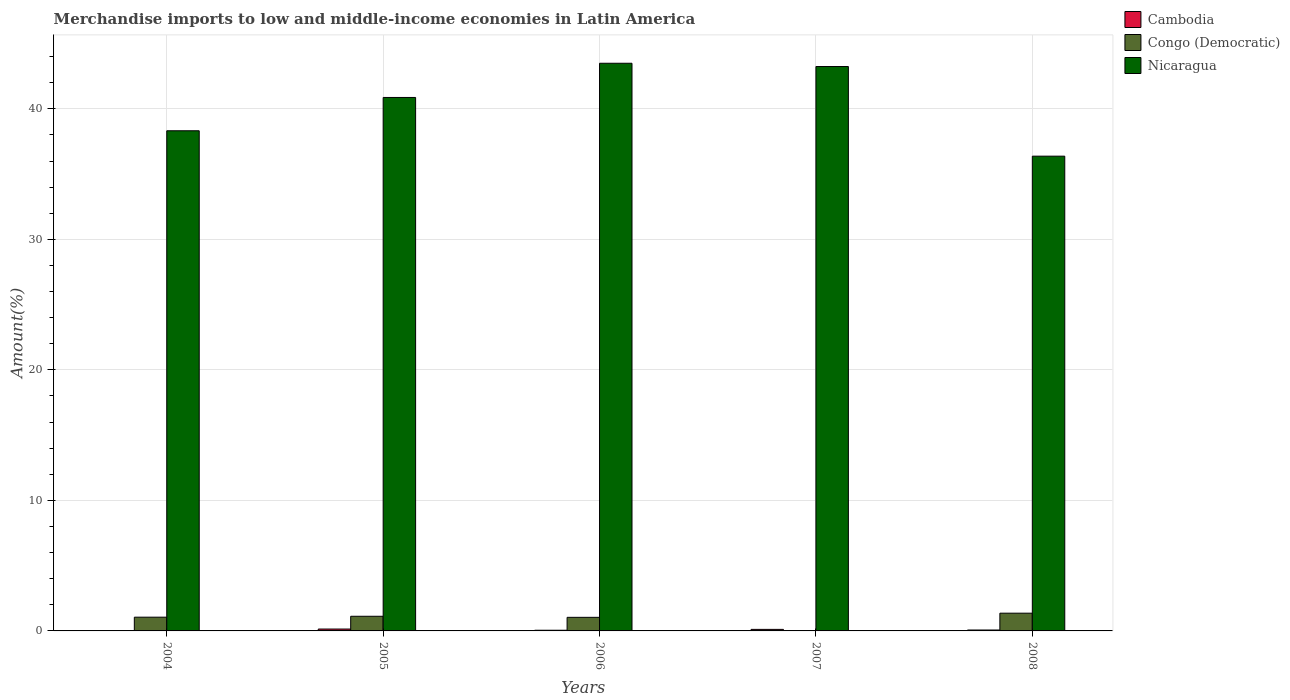Are the number of bars per tick equal to the number of legend labels?
Ensure brevity in your answer.  Yes. Are the number of bars on each tick of the X-axis equal?
Ensure brevity in your answer.  Yes. How many bars are there on the 5th tick from the left?
Make the answer very short. 3. How many bars are there on the 5th tick from the right?
Your answer should be compact. 3. In how many cases, is the number of bars for a given year not equal to the number of legend labels?
Provide a short and direct response. 0. What is the percentage of amount earned from merchandise imports in Cambodia in 2007?
Ensure brevity in your answer.  0.12. Across all years, what is the maximum percentage of amount earned from merchandise imports in Cambodia?
Give a very brief answer. 0.14. Across all years, what is the minimum percentage of amount earned from merchandise imports in Congo (Democratic)?
Offer a terse response. 0.03. In which year was the percentage of amount earned from merchandise imports in Cambodia minimum?
Give a very brief answer. 2004. What is the total percentage of amount earned from merchandise imports in Congo (Democratic) in the graph?
Provide a short and direct response. 4.6. What is the difference between the percentage of amount earned from merchandise imports in Congo (Democratic) in 2006 and that in 2008?
Provide a short and direct response. -0.32. What is the difference between the percentage of amount earned from merchandise imports in Nicaragua in 2008 and the percentage of amount earned from merchandise imports in Cambodia in 2006?
Ensure brevity in your answer.  36.32. What is the average percentage of amount earned from merchandise imports in Nicaragua per year?
Offer a terse response. 40.46. In the year 2005, what is the difference between the percentage of amount earned from merchandise imports in Congo (Democratic) and percentage of amount earned from merchandise imports in Nicaragua?
Your answer should be compact. -39.75. In how many years, is the percentage of amount earned from merchandise imports in Nicaragua greater than 20 %?
Your response must be concise. 5. What is the ratio of the percentage of amount earned from merchandise imports in Cambodia in 2005 to that in 2006?
Your answer should be very brief. 2.75. Is the percentage of amount earned from merchandise imports in Cambodia in 2007 less than that in 2008?
Ensure brevity in your answer.  No. Is the difference between the percentage of amount earned from merchandise imports in Congo (Democratic) in 2004 and 2007 greater than the difference between the percentage of amount earned from merchandise imports in Nicaragua in 2004 and 2007?
Your answer should be very brief. Yes. What is the difference between the highest and the second highest percentage of amount earned from merchandise imports in Cambodia?
Ensure brevity in your answer.  0.03. What is the difference between the highest and the lowest percentage of amount earned from merchandise imports in Cambodia?
Offer a very short reply. 0.13. What does the 2nd bar from the left in 2004 represents?
Ensure brevity in your answer.  Congo (Democratic). What does the 1st bar from the right in 2005 represents?
Your response must be concise. Nicaragua. Are all the bars in the graph horizontal?
Provide a succinct answer. No. How many years are there in the graph?
Give a very brief answer. 5. What is the difference between two consecutive major ticks on the Y-axis?
Make the answer very short. 10. Are the values on the major ticks of Y-axis written in scientific E-notation?
Keep it short and to the point. No. Does the graph contain grids?
Ensure brevity in your answer.  Yes. Where does the legend appear in the graph?
Keep it short and to the point. Top right. How are the legend labels stacked?
Your answer should be very brief. Vertical. What is the title of the graph?
Make the answer very short. Merchandise imports to low and middle-income economies in Latin America. What is the label or title of the Y-axis?
Ensure brevity in your answer.  Amount(%). What is the Amount(%) of Cambodia in 2004?
Ensure brevity in your answer.  0.02. What is the Amount(%) of Congo (Democratic) in 2004?
Offer a very short reply. 1.05. What is the Amount(%) in Nicaragua in 2004?
Your answer should be compact. 38.32. What is the Amount(%) in Cambodia in 2005?
Offer a very short reply. 0.14. What is the Amount(%) of Congo (Democratic) in 2005?
Your response must be concise. 1.12. What is the Amount(%) of Nicaragua in 2005?
Offer a terse response. 40.87. What is the Amount(%) of Cambodia in 2006?
Ensure brevity in your answer.  0.05. What is the Amount(%) of Congo (Democratic) in 2006?
Your answer should be very brief. 1.04. What is the Amount(%) of Nicaragua in 2006?
Make the answer very short. 43.49. What is the Amount(%) of Cambodia in 2007?
Offer a very short reply. 0.12. What is the Amount(%) in Congo (Democratic) in 2007?
Make the answer very short. 0.03. What is the Amount(%) in Nicaragua in 2007?
Provide a short and direct response. 43.24. What is the Amount(%) in Cambodia in 2008?
Provide a short and direct response. 0.07. What is the Amount(%) of Congo (Democratic) in 2008?
Your answer should be very brief. 1.36. What is the Amount(%) of Nicaragua in 2008?
Provide a short and direct response. 36.37. Across all years, what is the maximum Amount(%) in Cambodia?
Provide a succinct answer. 0.14. Across all years, what is the maximum Amount(%) in Congo (Democratic)?
Keep it short and to the point. 1.36. Across all years, what is the maximum Amount(%) in Nicaragua?
Give a very brief answer. 43.49. Across all years, what is the minimum Amount(%) of Cambodia?
Make the answer very short. 0.02. Across all years, what is the minimum Amount(%) of Congo (Democratic)?
Provide a short and direct response. 0.03. Across all years, what is the minimum Amount(%) in Nicaragua?
Keep it short and to the point. 36.37. What is the total Amount(%) in Cambodia in the graph?
Offer a very short reply. 0.4. What is the total Amount(%) of Congo (Democratic) in the graph?
Your response must be concise. 4.6. What is the total Amount(%) in Nicaragua in the graph?
Keep it short and to the point. 202.29. What is the difference between the Amount(%) in Cambodia in 2004 and that in 2005?
Your response must be concise. -0.13. What is the difference between the Amount(%) of Congo (Democratic) in 2004 and that in 2005?
Ensure brevity in your answer.  -0.07. What is the difference between the Amount(%) in Nicaragua in 2004 and that in 2005?
Give a very brief answer. -2.55. What is the difference between the Amount(%) of Cambodia in 2004 and that in 2006?
Your response must be concise. -0.04. What is the difference between the Amount(%) of Congo (Democratic) in 2004 and that in 2006?
Provide a short and direct response. 0.01. What is the difference between the Amount(%) in Nicaragua in 2004 and that in 2006?
Provide a short and direct response. -5.17. What is the difference between the Amount(%) of Cambodia in 2004 and that in 2007?
Offer a very short reply. -0.1. What is the difference between the Amount(%) in Congo (Democratic) in 2004 and that in 2007?
Your answer should be compact. 1.03. What is the difference between the Amount(%) of Nicaragua in 2004 and that in 2007?
Provide a succinct answer. -4.92. What is the difference between the Amount(%) of Cambodia in 2004 and that in 2008?
Keep it short and to the point. -0.05. What is the difference between the Amount(%) of Congo (Democratic) in 2004 and that in 2008?
Keep it short and to the point. -0.31. What is the difference between the Amount(%) in Nicaragua in 2004 and that in 2008?
Offer a terse response. 1.95. What is the difference between the Amount(%) in Cambodia in 2005 and that in 2006?
Give a very brief answer. 0.09. What is the difference between the Amount(%) of Congo (Democratic) in 2005 and that in 2006?
Offer a very short reply. 0.08. What is the difference between the Amount(%) in Nicaragua in 2005 and that in 2006?
Provide a succinct answer. -2.62. What is the difference between the Amount(%) in Cambodia in 2005 and that in 2007?
Keep it short and to the point. 0.03. What is the difference between the Amount(%) in Congo (Democratic) in 2005 and that in 2007?
Your answer should be compact. 1.1. What is the difference between the Amount(%) of Nicaragua in 2005 and that in 2007?
Provide a succinct answer. -2.37. What is the difference between the Amount(%) of Cambodia in 2005 and that in 2008?
Give a very brief answer. 0.07. What is the difference between the Amount(%) in Congo (Democratic) in 2005 and that in 2008?
Your response must be concise. -0.24. What is the difference between the Amount(%) of Nicaragua in 2005 and that in 2008?
Keep it short and to the point. 4.5. What is the difference between the Amount(%) in Cambodia in 2006 and that in 2007?
Keep it short and to the point. -0.07. What is the difference between the Amount(%) of Congo (Democratic) in 2006 and that in 2007?
Your response must be concise. 1.02. What is the difference between the Amount(%) in Nicaragua in 2006 and that in 2007?
Your response must be concise. 0.25. What is the difference between the Amount(%) of Cambodia in 2006 and that in 2008?
Keep it short and to the point. -0.02. What is the difference between the Amount(%) of Congo (Democratic) in 2006 and that in 2008?
Your answer should be compact. -0.32. What is the difference between the Amount(%) of Nicaragua in 2006 and that in 2008?
Your response must be concise. 7.12. What is the difference between the Amount(%) in Cambodia in 2007 and that in 2008?
Your answer should be very brief. 0.05. What is the difference between the Amount(%) in Congo (Democratic) in 2007 and that in 2008?
Provide a short and direct response. -1.33. What is the difference between the Amount(%) of Nicaragua in 2007 and that in 2008?
Your answer should be very brief. 6.87. What is the difference between the Amount(%) in Cambodia in 2004 and the Amount(%) in Congo (Democratic) in 2005?
Your answer should be compact. -1.1. What is the difference between the Amount(%) of Cambodia in 2004 and the Amount(%) of Nicaragua in 2005?
Keep it short and to the point. -40.85. What is the difference between the Amount(%) in Congo (Democratic) in 2004 and the Amount(%) in Nicaragua in 2005?
Ensure brevity in your answer.  -39.82. What is the difference between the Amount(%) of Cambodia in 2004 and the Amount(%) of Congo (Democratic) in 2006?
Give a very brief answer. -1.02. What is the difference between the Amount(%) of Cambodia in 2004 and the Amount(%) of Nicaragua in 2006?
Provide a short and direct response. -43.47. What is the difference between the Amount(%) in Congo (Democratic) in 2004 and the Amount(%) in Nicaragua in 2006?
Provide a short and direct response. -42.44. What is the difference between the Amount(%) in Cambodia in 2004 and the Amount(%) in Congo (Democratic) in 2007?
Your response must be concise. -0.01. What is the difference between the Amount(%) in Cambodia in 2004 and the Amount(%) in Nicaragua in 2007?
Your answer should be compact. -43.22. What is the difference between the Amount(%) of Congo (Democratic) in 2004 and the Amount(%) of Nicaragua in 2007?
Provide a short and direct response. -42.19. What is the difference between the Amount(%) of Cambodia in 2004 and the Amount(%) of Congo (Democratic) in 2008?
Your response must be concise. -1.34. What is the difference between the Amount(%) of Cambodia in 2004 and the Amount(%) of Nicaragua in 2008?
Give a very brief answer. -36.35. What is the difference between the Amount(%) in Congo (Democratic) in 2004 and the Amount(%) in Nicaragua in 2008?
Your response must be concise. -35.32. What is the difference between the Amount(%) in Cambodia in 2005 and the Amount(%) in Congo (Democratic) in 2006?
Provide a succinct answer. -0.9. What is the difference between the Amount(%) of Cambodia in 2005 and the Amount(%) of Nicaragua in 2006?
Make the answer very short. -43.35. What is the difference between the Amount(%) in Congo (Democratic) in 2005 and the Amount(%) in Nicaragua in 2006?
Keep it short and to the point. -42.37. What is the difference between the Amount(%) in Cambodia in 2005 and the Amount(%) in Congo (Democratic) in 2007?
Make the answer very short. 0.12. What is the difference between the Amount(%) of Cambodia in 2005 and the Amount(%) of Nicaragua in 2007?
Ensure brevity in your answer.  -43.09. What is the difference between the Amount(%) in Congo (Democratic) in 2005 and the Amount(%) in Nicaragua in 2007?
Ensure brevity in your answer.  -42.12. What is the difference between the Amount(%) in Cambodia in 2005 and the Amount(%) in Congo (Democratic) in 2008?
Your answer should be compact. -1.21. What is the difference between the Amount(%) of Cambodia in 2005 and the Amount(%) of Nicaragua in 2008?
Offer a very short reply. -36.23. What is the difference between the Amount(%) in Congo (Democratic) in 2005 and the Amount(%) in Nicaragua in 2008?
Ensure brevity in your answer.  -35.25. What is the difference between the Amount(%) in Cambodia in 2006 and the Amount(%) in Congo (Democratic) in 2007?
Keep it short and to the point. 0.03. What is the difference between the Amount(%) in Cambodia in 2006 and the Amount(%) in Nicaragua in 2007?
Make the answer very short. -43.19. What is the difference between the Amount(%) in Congo (Democratic) in 2006 and the Amount(%) in Nicaragua in 2007?
Make the answer very short. -42.2. What is the difference between the Amount(%) in Cambodia in 2006 and the Amount(%) in Congo (Democratic) in 2008?
Offer a terse response. -1.31. What is the difference between the Amount(%) in Cambodia in 2006 and the Amount(%) in Nicaragua in 2008?
Offer a terse response. -36.32. What is the difference between the Amount(%) in Congo (Democratic) in 2006 and the Amount(%) in Nicaragua in 2008?
Your response must be concise. -35.33. What is the difference between the Amount(%) in Cambodia in 2007 and the Amount(%) in Congo (Democratic) in 2008?
Your response must be concise. -1.24. What is the difference between the Amount(%) in Cambodia in 2007 and the Amount(%) in Nicaragua in 2008?
Keep it short and to the point. -36.25. What is the difference between the Amount(%) of Congo (Democratic) in 2007 and the Amount(%) of Nicaragua in 2008?
Your answer should be very brief. -36.35. What is the average Amount(%) in Cambodia per year?
Keep it short and to the point. 0.08. What is the average Amount(%) in Congo (Democratic) per year?
Keep it short and to the point. 0.92. What is the average Amount(%) in Nicaragua per year?
Provide a short and direct response. 40.46. In the year 2004, what is the difference between the Amount(%) of Cambodia and Amount(%) of Congo (Democratic)?
Provide a short and direct response. -1.04. In the year 2004, what is the difference between the Amount(%) of Cambodia and Amount(%) of Nicaragua?
Your answer should be compact. -38.3. In the year 2004, what is the difference between the Amount(%) of Congo (Democratic) and Amount(%) of Nicaragua?
Your response must be concise. -37.27. In the year 2005, what is the difference between the Amount(%) of Cambodia and Amount(%) of Congo (Democratic)?
Offer a terse response. -0.98. In the year 2005, what is the difference between the Amount(%) of Cambodia and Amount(%) of Nicaragua?
Ensure brevity in your answer.  -40.73. In the year 2005, what is the difference between the Amount(%) of Congo (Democratic) and Amount(%) of Nicaragua?
Provide a succinct answer. -39.75. In the year 2006, what is the difference between the Amount(%) of Cambodia and Amount(%) of Congo (Democratic)?
Provide a succinct answer. -0.99. In the year 2006, what is the difference between the Amount(%) of Cambodia and Amount(%) of Nicaragua?
Provide a short and direct response. -43.44. In the year 2006, what is the difference between the Amount(%) in Congo (Democratic) and Amount(%) in Nicaragua?
Ensure brevity in your answer.  -42.45. In the year 2007, what is the difference between the Amount(%) in Cambodia and Amount(%) in Congo (Democratic)?
Offer a terse response. 0.09. In the year 2007, what is the difference between the Amount(%) of Cambodia and Amount(%) of Nicaragua?
Your answer should be compact. -43.12. In the year 2007, what is the difference between the Amount(%) in Congo (Democratic) and Amount(%) in Nicaragua?
Provide a succinct answer. -43.21. In the year 2008, what is the difference between the Amount(%) in Cambodia and Amount(%) in Congo (Democratic)?
Your response must be concise. -1.29. In the year 2008, what is the difference between the Amount(%) in Cambodia and Amount(%) in Nicaragua?
Your response must be concise. -36.3. In the year 2008, what is the difference between the Amount(%) of Congo (Democratic) and Amount(%) of Nicaragua?
Offer a terse response. -35.01. What is the ratio of the Amount(%) in Cambodia in 2004 to that in 2005?
Provide a succinct answer. 0.12. What is the ratio of the Amount(%) of Congo (Democratic) in 2004 to that in 2005?
Keep it short and to the point. 0.94. What is the ratio of the Amount(%) of Nicaragua in 2004 to that in 2005?
Provide a short and direct response. 0.94. What is the ratio of the Amount(%) of Cambodia in 2004 to that in 2006?
Keep it short and to the point. 0.33. What is the ratio of the Amount(%) in Congo (Democratic) in 2004 to that in 2006?
Ensure brevity in your answer.  1.01. What is the ratio of the Amount(%) of Nicaragua in 2004 to that in 2006?
Give a very brief answer. 0.88. What is the ratio of the Amount(%) of Cambodia in 2004 to that in 2007?
Provide a short and direct response. 0.15. What is the ratio of the Amount(%) in Congo (Democratic) in 2004 to that in 2007?
Provide a succinct answer. 41.59. What is the ratio of the Amount(%) of Nicaragua in 2004 to that in 2007?
Keep it short and to the point. 0.89. What is the ratio of the Amount(%) of Cambodia in 2004 to that in 2008?
Make the answer very short. 0.25. What is the ratio of the Amount(%) of Congo (Democratic) in 2004 to that in 2008?
Give a very brief answer. 0.77. What is the ratio of the Amount(%) in Nicaragua in 2004 to that in 2008?
Your answer should be very brief. 1.05. What is the ratio of the Amount(%) of Cambodia in 2005 to that in 2006?
Your answer should be very brief. 2.75. What is the ratio of the Amount(%) of Congo (Democratic) in 2005 to that in 2006?
Ensure brevity in your answer.  1.08. What is the ratio of the Amount(%) in Nicaragua in 2005 to that in 2006?
Keep it short and to the point. 0.94. What is the ratio of the Amount(%) of Cambodia in 2005 to that in 2007?
Your answer should be very brief. 1.22. What is the ratio of the Amount(%) in Congo (Democratic) in 2005 to that in 2007?
Give a very brief answer. 44.34. What is the ratio of the Amount(%) of Nicaragua in 2005 to that in 2007?
Your answer should be very brief. 0.95. What is the ratio of the Amount(%) in Cambodia in 2005 to that in 2008?
Offer a very short reply. 2.07. What is the ratio of the Amount(%) of Congo (Democratic) in 2005 to that in 2008?
Your answer should be very brief. 0.83. What is the ratio of the Amount(%) of Nicaragua in 2005 to that in 2008?
Ensure brevity in your answer.  1.12. What is the ratio of the Amount(%) in Cambodia in 2006 to that in 2007?
Provide a succinct answer. 0.45. What is the ratio of the Amount(%) in Congo (Democratic) in 2006 to that in 2007?
Provide a short and direct response. 41.11. What is the ratio of the Amount(%) of Nicaragua in 2006 to that in 2007?
Keep it short and to the point. 1.01. What is the ratio of the Amount(%) in Cambodia in 2006 to that in 2008?
Your response must be concise. 0.75. What is the ratio of the Amount(%) of Congo (Democratic) in 2006 to that in 2008?
Give a very brief answer. 0.77. What is the ratio of the Amount(%) in Nicaragua in 2006 to that in 2008?
Your answer should be very brief. 1.2. What is the ratio of the Amount(%) of Cambodia in 2007 to that in 2008?
Offer a very short reply. 1.69. What is the ratio of the Amount(%) of Congo (Democratic) in 2007 to that in 2008?
Keep it short and to the point. 0.02. What is the ratio of the Amount(%) in Nicaragua in 2007 to that in 2008?
Your answer should be compact. 1.19. What is the difference between the highest and the second highest Amount(%) in Cambodia?
Make the answer very short. 0.03. What is the difference between the highest and the second highest Amount(%) of Congo (Democratic)?
Your response must be concise. 0.24. What is the difference between the highest and the second highest Amount(%) of Nicaragua?
Keep it short and to the point. 0.25. What is the difference between the highest and the lowest Amount(%) of Cambodia?
Provide a succinct answer. 0.13. What is the difference between the highest and the lowest Amount(%) in Congo (Democratic)?
Offer a very short reply. 1.33. What is the difference between the highest and the lowest Amount(%) of Nicaragua?
Give a very brief answer. 7.12. 